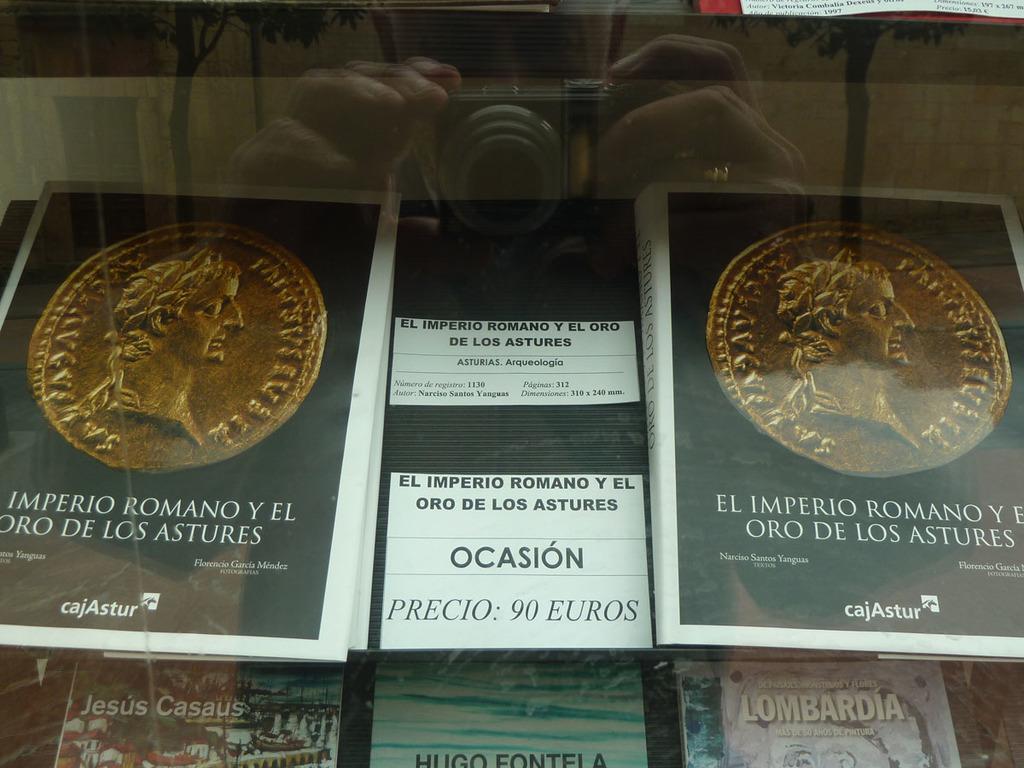Could you give a brief overview of what you see in this image? In the foreground of this image, it seems like books inside the glass and in the reflection, there is a man holding a camera. 